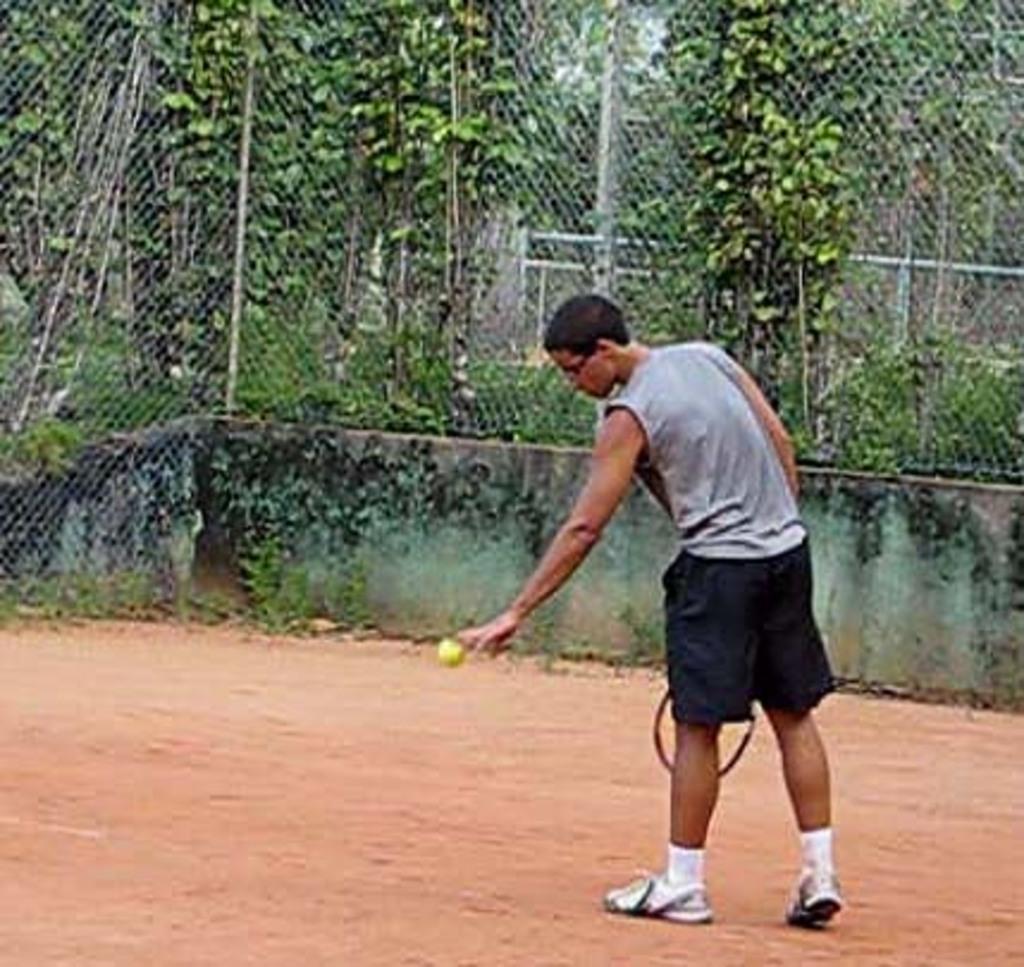How would you summarize this image in a sentence or two? As we can see in the image there are trees, fence and a man holding shuttle bat and boll. 